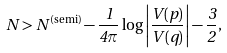<formula> <loc_0><loc_0><loc_500><loc_500>N > N ^ { \text {(semi)} } - \frac { 1 } { 4 \pi } \log \left | \frac { V ( p ) } { V ( q ) } \right | - \frac { 3 } { 2 } ,</formula> 